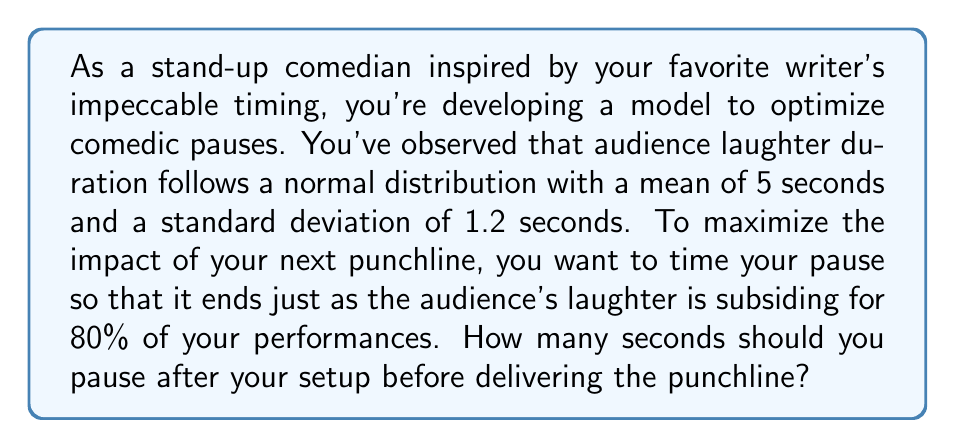What is the answer to this math problem? To solve this problem, we need to use the properties of the normal distribution and the concept of z-scores.

1) First, we identify the given information:
   - Laughter duration follows a normal distribution
   - Mean (μ) = 5 seconds
   - Standard deviation (σ) = 1.2 seconds
   - We want to find the time that covers 80% of the distribution

2) In a normal distribution, we can use z-scores to find the value that corresponds to a certain percentile. We want the 80th percentile, which means 20% of the distribution is above this point.

3) Using a standard normal distribution table or calculator, we find that the z-score for the 80th percentile is approximately 0.84.

4) The formula for z-score is:
   $$ z = \frac{x - μ}{σ} $$
   where x is the value we're looking for.

5) Substituting our known values:
   $$ 0.84 = \frac{x - 5}{1.2} $$

6) Solving for x:
   $$ 0.84 * 1.2 = x - 5 $$
   $$ 1.008 = x - 5 $$
   $$ x = 6.008 $$

7) Rounding to two decimal places, we get 6.01 seconds.

This means that to have your punchline land just as the laughter is subsiding for 80% of your performances, you should pause for 6.01 seconds after your setup.
Answer: The optimal pause duration is 6.01 seconds. 